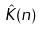Convert formula to latex. <formula><loc_0><loc_0><loc_500><loc_500>\hat { K } ( n )</formula> 